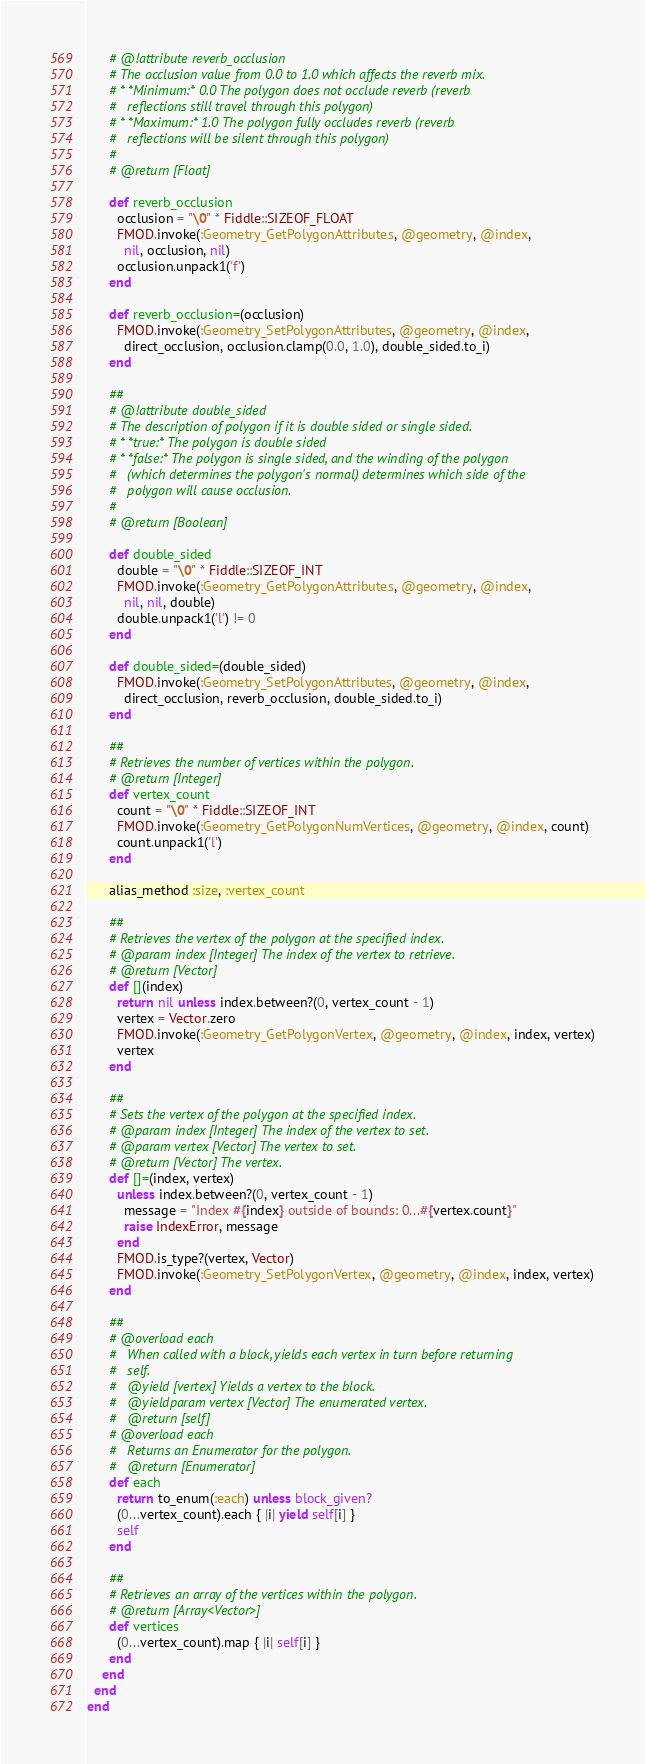Convert code to text. <code><loc_0><loc_0><loc_500><loc_500><_Ruby_>      # @!attribute reverb_occlusion
      # The occlusion value from 0.0 to 1.0 which affects the reverb mix.
      # * *Minimum:* 0.0 The polygon does not occlude reverb (reverb
      #   reflections still travel through this polygon)
      # * *Maximum:* 1.0 The polygon fully occludes reverb (reverb
      #   reflections will be silent through this polygon)
      #
      # @return [Float]

      def reverb_occlusion
        occlusion = "\0" * Fiddle::SIZEOF_FLOAT
        FMOD.invoke(:Geometry_GetPolygonAttributes, @geometry, @index,
          nil, occlusion, nil)
        occlusion.unpack1('f')
      end

      def reverb_occlusion=(occlusion)
        FMOD.invoke(:Geometry_SetPolygonAttributes, @geometry, @index,
          direct_occlusion, occlusion.clamp(0.0, 1.0), double_sided.to_i)
      end

      ##
      # @!attribute double_sided
      # The description of polygon if it is double sided or single sided.
      # * *true:* The polygon is double sided
      # * *false:* The polygon is single sided, and the winding of the polygon
      #   (which determines the polygon's normal) determines which side of the
      #   polygon will cause occlusion.
      #
      # @return [Boolean]

      def double_sided
        double = "\0" * Fiddle::SIZEOF_INT
        FMOD.invoke(:Geometry_GetPolygonAttributes, @geometry, @index,
          nil, nil, double)
        double.unpack1('l') != 0
      end

      def double_sided=(double_sided)
        FMOD.invoke(:Geometry_SetPolygonAttributes, @geometry, @index,
          direct_occlusion, reverb_occlusion, double_sided.to_i)
      end

      ##
      # Retrieves the number of vertices within the polygon.
      # @return [Integer]
      def vertex_count
        count = "\0" * Fiddle::SIZEOF_INT
        FMOD.invoke(:Geometry_GetPolygonNumVertices, @geometry, @index, count)
        count.unpack1('l')
      end

      alias_method :size, :vertex_count

      ##
      # Retrieves the vertex of the polygon at the specified index.
      # @param index [Integer] The index of the vertex to retrieve.
      # @return [Vector]
      def [](index)
        return nil unless index.between?(0, vertex_count - 1)
        vertex = Vector.zero
        FMOD.invoke(:Geometry_GetPolygonVertex, @geometry, @index, index, vertex)
        vertex
      end

      ##
      # Sets the vertex of the polygon at the specified index.
      # @param index [Integer] The index of the vertex to set.
      # @param vertex [Vector] The vertex to set.
      # @return [Vector] The vertex.
      def []=(index, vertex)
        unless index.between?(0, vertex_count - 1)
          message = "Index #{index} outside of bounds: 0...#{vertex.count}"
          raise IndexError, message
        end
        FMOD.is_type?(vertex, Vector)
        FMOD.invoke(:Geometry_SetPolygonVertex, @geometry, @index, index, vertex)
      end

      ##
      # @overload each
      #   When called with a block, yields each vertex in turn before returning
      #   self.
      #   @yield [vertex] Yields a vertex to the block.
      #   @yieldparam vertex [Vector] The enumerated vertex.
      #   @return [self]
      # @overload each
      #   Returns an Enumerator for the polygon.
      #   @return [Enumerator]
      def each
        return to_enum(:each) unless block_given?
        (0...vertex_count).each { |i| yield self[i] }
        self
      end

      ##
      # Retrieves an array of the vertices within the polygon.
      # @return [Array<Vector>]
      def vertices
        (0...vertex_count).map { |i| self[i] }
      end
    end
  end
end</code> 